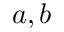Convert formula to latex. <formula><loc_0><loc_0><loc_500><loc_500>a , b</formula> 